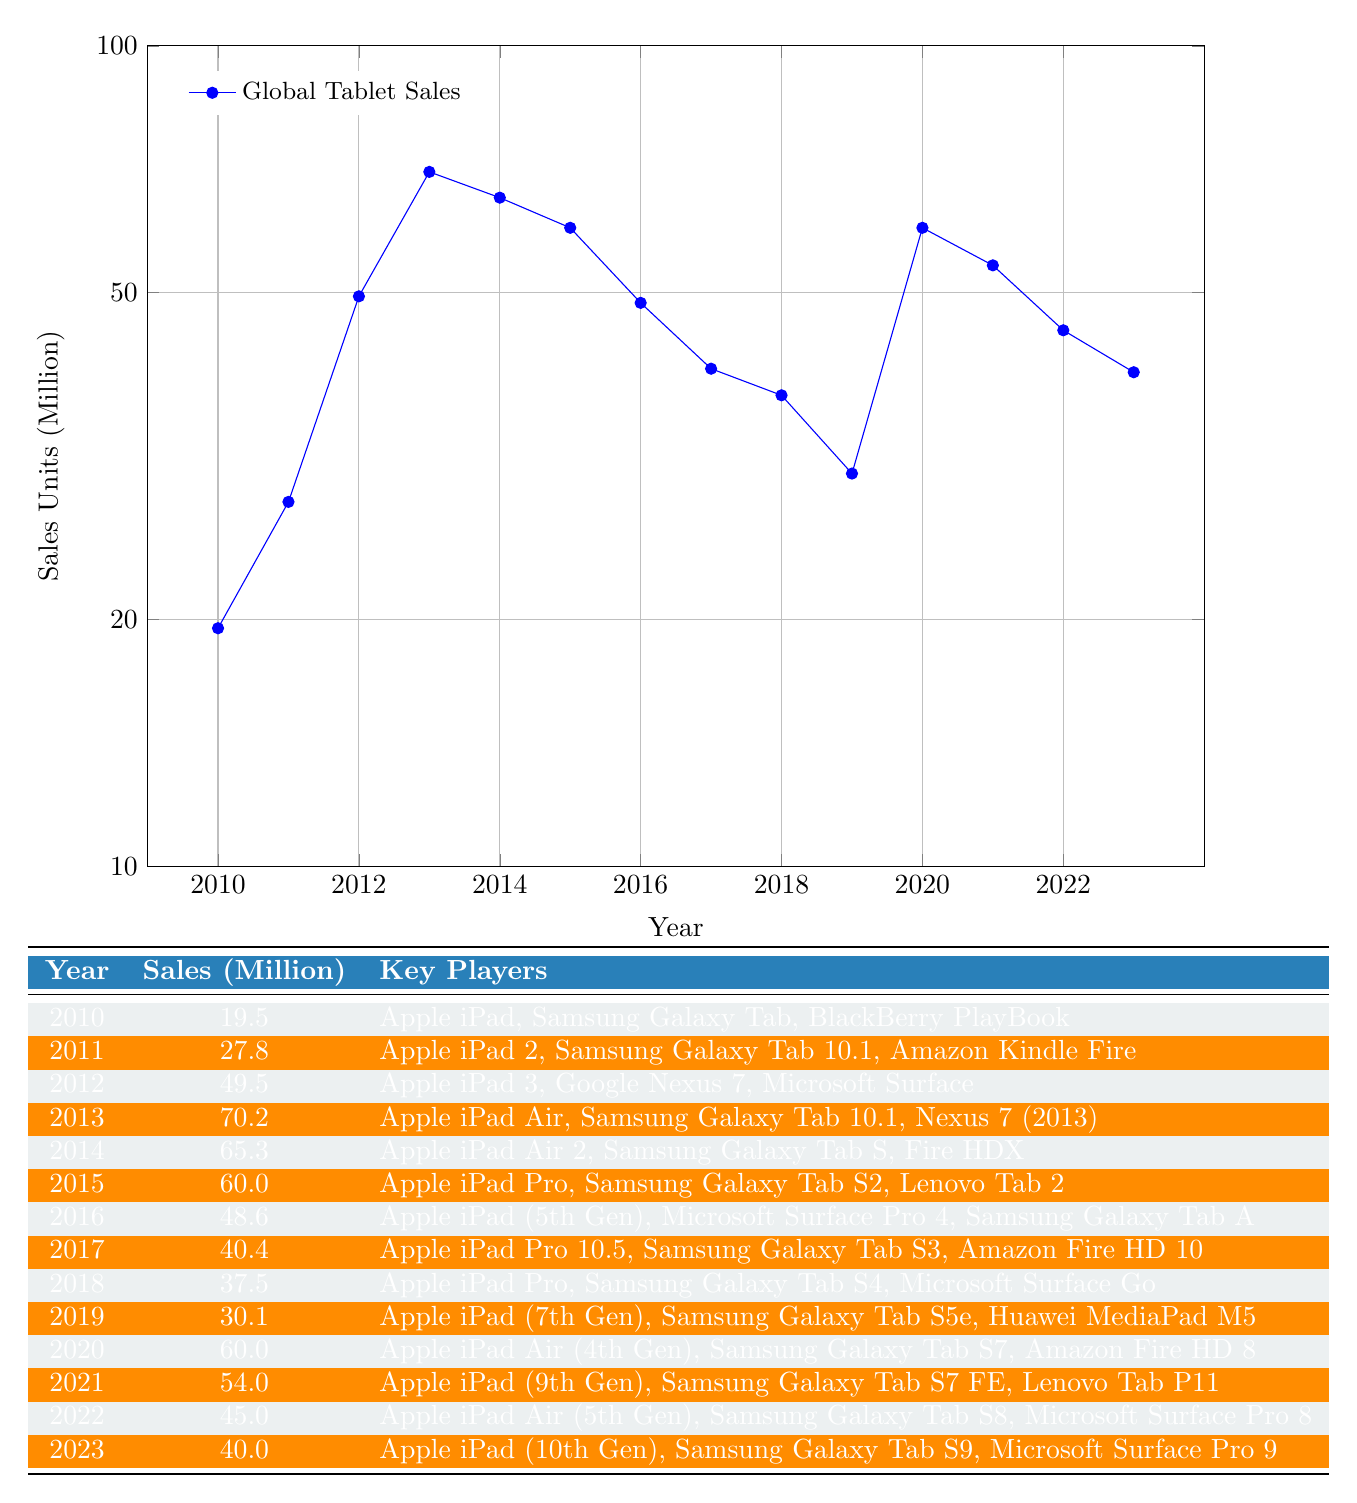What were the total tablet sales from 2010 to 2023? To find the total, we sum the sales units for each year: 19.5 + 27.8 + 49.5 + 70.2 + 65.3 + 60.0 + 48.6 + 40.4 + 37.5 + 30.1 + 60.0 + 54.0 + 45.0 + 40.0 =  651.5 million units.
Answer: 651.5 million Which year had the highest tablet sales? Looking through the sales units in the table, 2013 has the highest sales at 70.2 million units.
Answer: 2013 Was 2021's sales higher than 2022's? Comparing the sales units, 2021 had 54.0 million while 2022 had 45.0 million, so 2021's sales were higher than 2022's.
Answer: Yes What is the average sales of tablets from 2010 to 2023? We sum the sales units (651.5 million) and divide by the number of years (14); thus, 651.5 / 14 = 46.5 million units.
Answer: 46.5 million In which year did sales first exceed 40 million? Looking at the sales data, sales exceeded 40 million for the first time in 2012, with 49.5 million units sold.
Answer: 2012 Did Samsung release a tablet in every year from 2010 to 2023? Checking the key players each year, Samsung is listed as having released a tablet every year from 2010 to 2023.
Answer: Yes What was the percentage decrease in sales from 2012 to 2013? Sales in 2012 were 49.5 million and in 2013, they were 70.2 million. The formula for percentage decrease is ((new value - old value) / old value) * 100. In this case: ((70.2 - 49.5) / 49.5) * 100 = approximately 41.5%.
Answer: Approximately 41.5% Which year saw a noticeable decline in sales directly after 2013? 2014 saw a decline in sales from 70.2 million (2013) to 65.3 million, making it the noticeable decline right after 2013.
Answer: 2014 Between 2015 and 2021, what was the maximum sales value recorded? The sales for these years are: 60.0 (2015), 54.0 (2021). The maximum is 60.0 million in 2015.
Answer: 60.0 million 